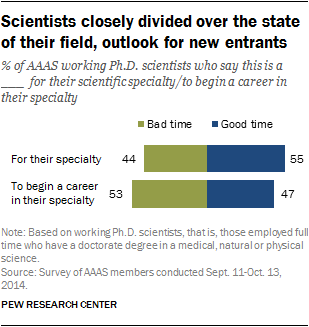Identify some key points in this picture. The color of the good time is blue. The values 44 and 55 are the good and bad times for Specialty XYZ. 